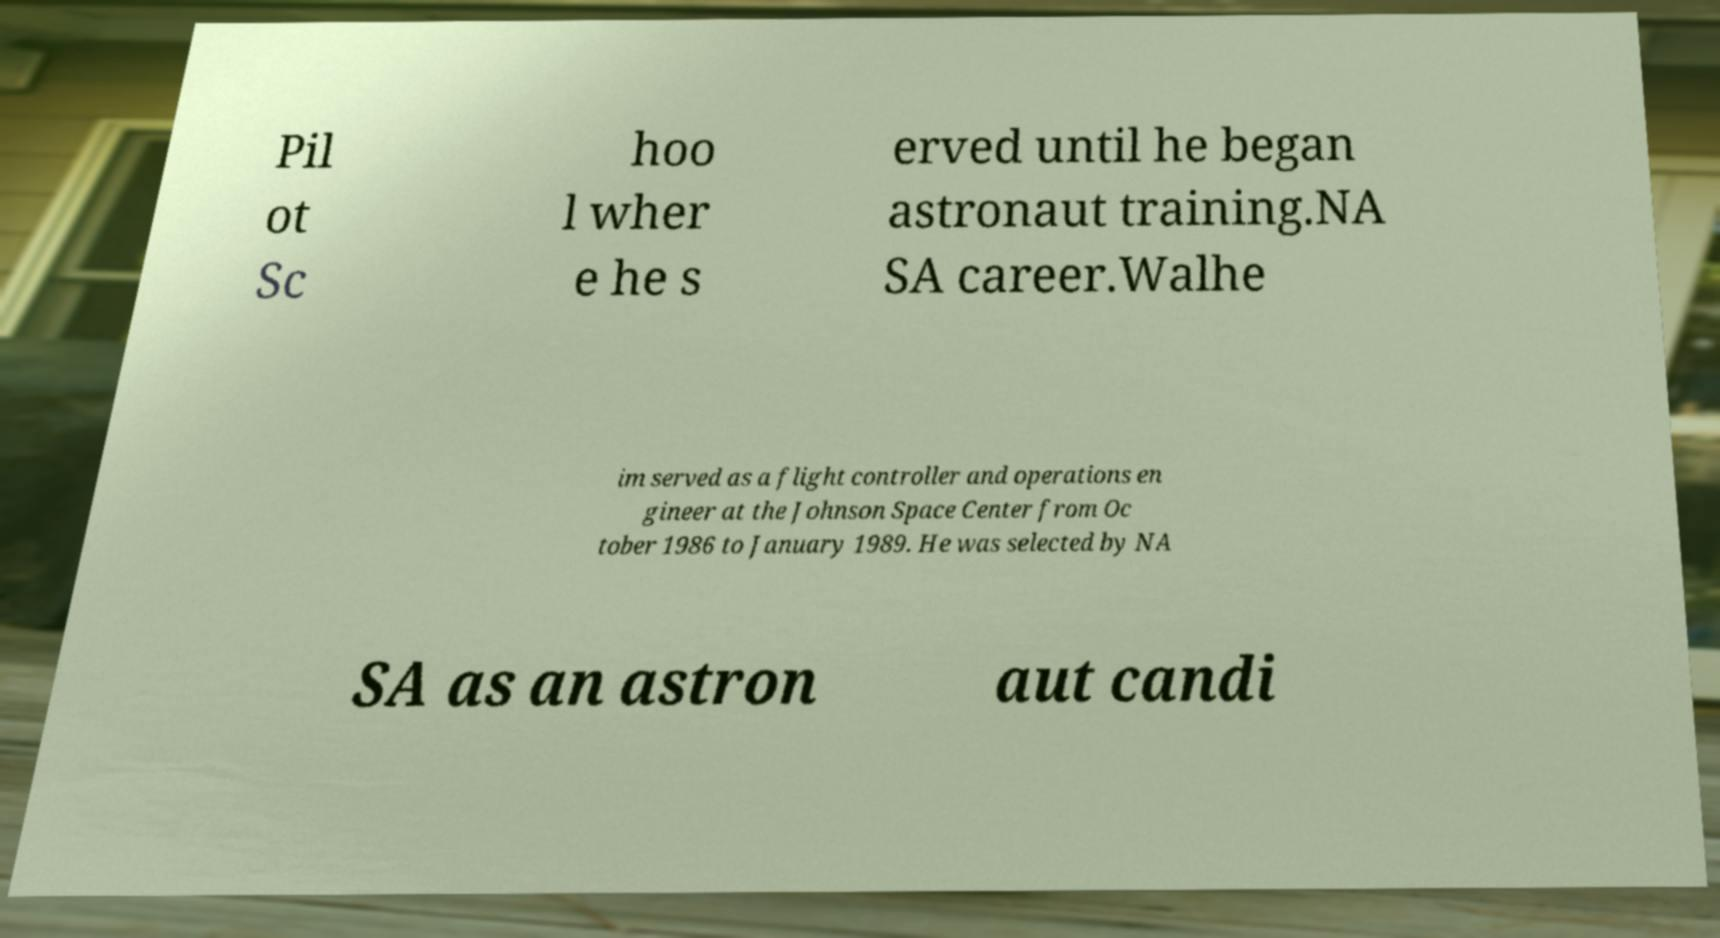Can you read and provide the text displayed in the image?This photo seems to have some interesting text. Can you extract and type it out for me? Pil ot Sc hoo l wher e he s erved until he began astronaut training.NA SA career.Walhe im served as a flight controller and operations en gineer at the Johnson Space Center from Oc tober 1986 to January 1989. He was selected by NA SA as an astron aut candi 